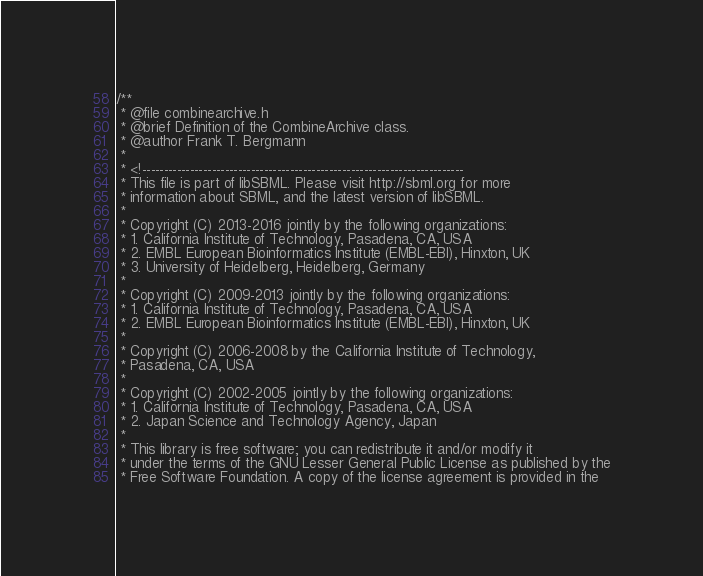Convert code to text. <code><loc_0><loc_0><loc_500><loc_500><_C_>/**
 * @file combinearchive.h
 * @brief Definition of the CombineArchive class.
 * @author Frank T. Bergmann
 *
 * <!--------------------------------------------------------------------------
 * This file is part of libSBML. Please visit http://sbml.org for more
 * information about SBML, and the latest version of libSBML.
 *
 * Copyright (C) 2013-2016 jointly by the following organizations:
 * 1. California Institute of Technology, Pasadena, CA, USA
 * 2. EMBL European Bioinformatics Institute (EMBL-EBI), Hinxton, UK
 * 3. University of Heidelberg, Heidelberg, Germany
 *
 * Copyright (C) 2009-2013 jointly by the following organizations:
 * 1. California Institute of Technology, Pasadena, CA, USA
 * 2. EMBL European Bioinformatics Institute (EMBL-EBI), Hinxton, UK
 *
 * Copyright (C) 2006-2008 by the California Institute of Technology,
 * Pasadena, CA, USA
 *
 * Copyright (C) 2002-2005 jointly by the following organizations:
 * 1. California Institute of Technology, Pasadena, CA, USA
 * 2. Japan Science and Technology Agency, Japan
 *
 * This library is free software; you can redistribute it and/or modify it
 * under the terms of the GNU Lesser General Public License as published by the
 * Free Software Foundation. A copy of the license agreement is provided in the</code> 